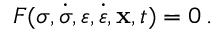Convert formula to latex. <formula><loc_0><loc_0><loc_500><loc_500>F ( { \sigma } , { \dot { \sigma } } , { \varepsilon } , { \dot { \varepsilon } } , x , t ) = 0 \, .</formula> 